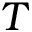<formula> <loc_0><loc_0><loc_500><loc_500>T</formula> 